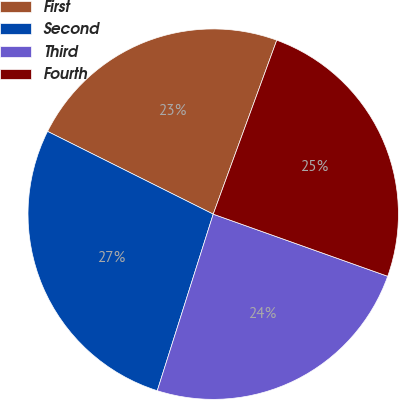Convert chart to OTSL. <chart><loc_0><loc_0><loc_500><loc_500><pie_chart><fcel>First<fcel>Second<fcel>Third<fcel>Fourth<nl><fcel>23.2%<fcel>27.49%<fcel>24.44%<fcel>24.87%<nl></chart> 